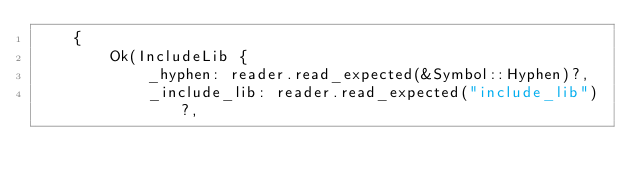<code> <loc_0><loc_0><loc_500><loc_500><_Rust_>    {
        Ok(IncludeLib {
            _hyphen: reader.read_expected(&Symbol::Hyphen)?,
            _include_lib: reader.read_expected("include_lib")?,</code> 